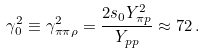Convert formula to latex. <formula><loc_0><loc_0><loc_500><loc_500>\gamma _ { 0 } ^ { 2 } \equiv \gamma _ { \pi \pi \rho } ^ { 2 } = { \frac { 2 s _ { 0 } Y _ { \pi p } ^ { 2 } } { Y _ { p p } } } \approx 7 2 \, .</formula> 